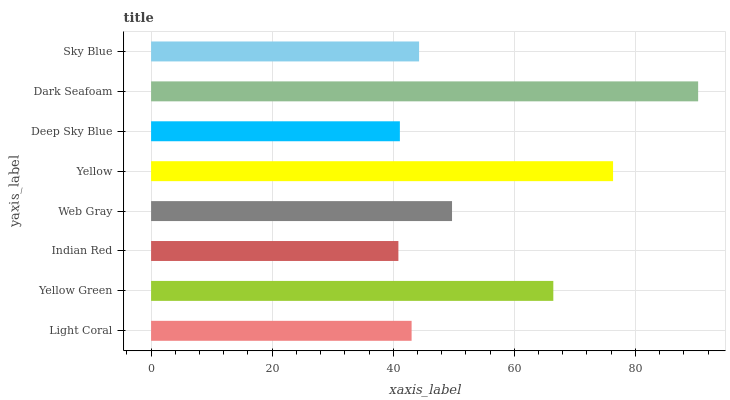Is Indian Red the minimum?
Answer yes or no. Yes. Is Dark Seafoam the maximum?
Answer yes or no. Yes. Is Yellow Green the minimum?
Answer yes or no. No. Is Yellow Green the maximum?
Answer yes or no. No. Is Yellow Green greater than Light Coral?
Answer yes or no. Yes. Is Light Coral less than Yellow Green?
Answer yes or no. Yes. Is Light Coral greater than Yellow Green?
Answer yes or no. No. Is Yellow Green less than Light Coral?
Answer yes or no. No. Is Web Gray the high median?
Answer yes or no. Yes. Is Sky Blue the low median?
Answer yes or no. Yes. Is Sky Blue the high median?
Answer yes or no. No. Is Indian Red the low median?
Answer yes or no. No. 